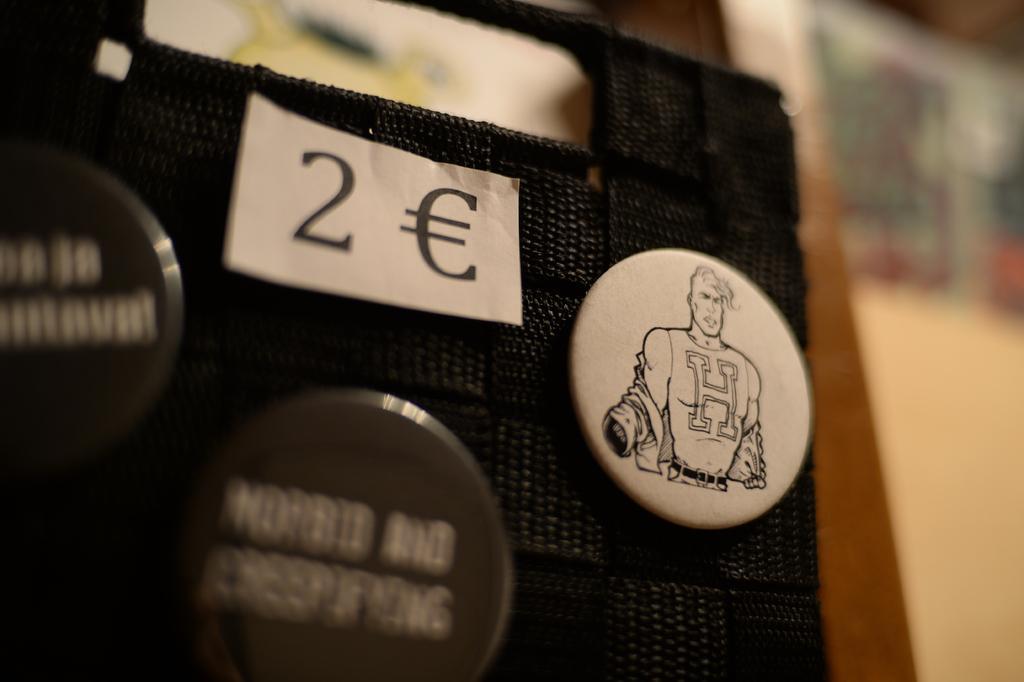How would you summarize this image in a sentence or two? In this image I can see three badges in black and white color and they are attached to the black color surface and I can see the blurred background. 